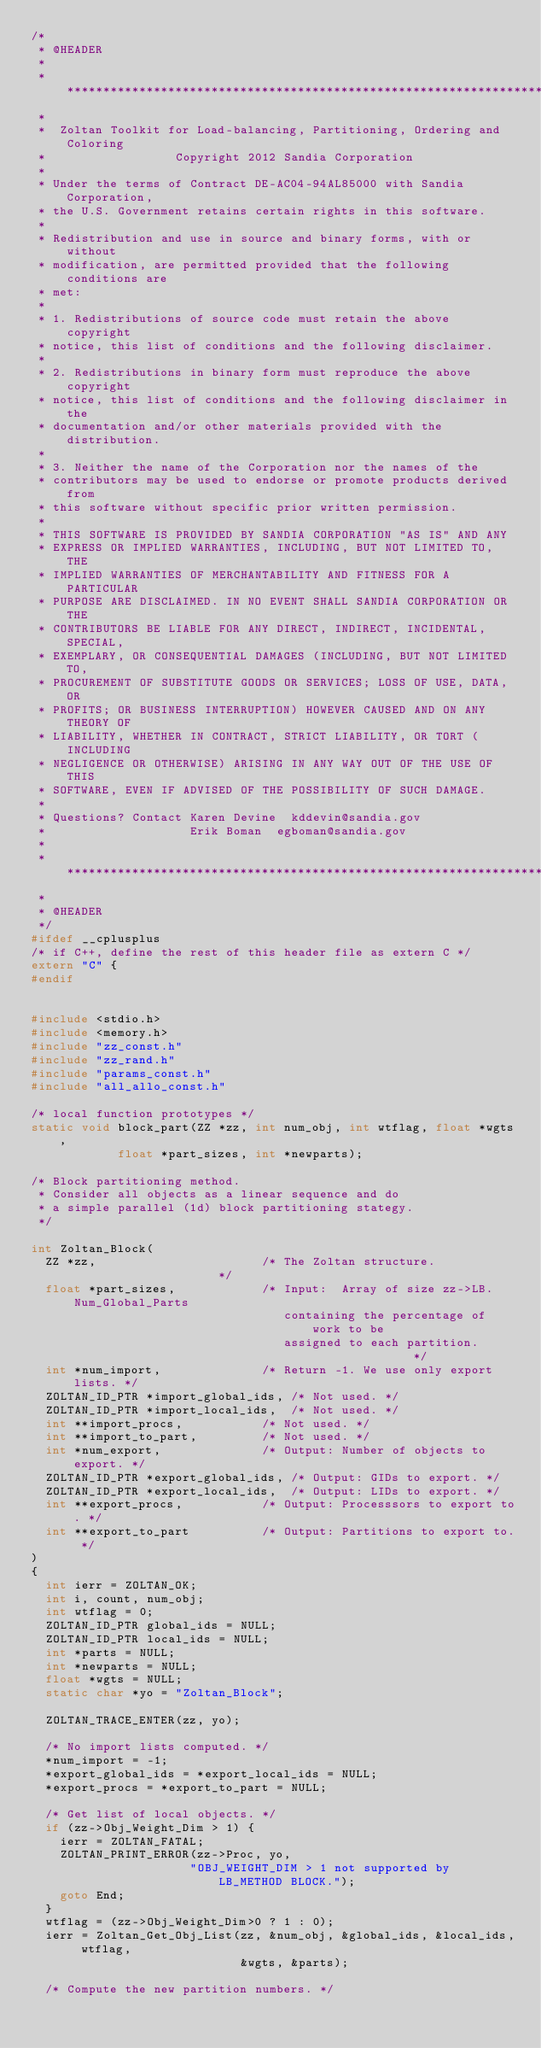<code> <loc_0><loc_0><loc_500><loc_500><_C_>/* 
 * @HEADER
 *
 * ***********************************************************************
 *
 *  Zoltan Toolkit for Load-balancing, Partitioning, Ordering and Coloring
 *                  Copyright 2012 Sandia Corporation
 *
 * Under the terms of Contract DE-AC04-94AL85000 with Sandia Corporation,
 * the U.S. Government retains certain rights in this software.
 *
 * Redistribution and use in source and binary forms, with or without
 * modification, are permitted provided that the following conditions are
 * met:
 *
 * 1. Redistributions of source code must retain the above copyright
 * notice, this list of conditions and the following disclaimer.
 *
 * 2. Redistributions in binary form must reproduce the above copyright
 * notice, this list of conditions and the following disclaimer in the
 * documentation and/or other materials provided with the distribution.
 *
 * 3. Neither the name of the Corporation nor the names of the
 * contributors may be used to endorse or promote products derived from
 * this software without specific prior written permission.
 *
 * THIS SOFTWARE IS PROVIDED BY SANDIA CORPORATION "AS IS" AND ANY
 * EXPRESS OR IMPLIED WARRANTIES, INCLUDING, BUT NOT LIMITED TO, THE
 * IMPLIED WARRANTIES OF MERCHANTABILITY AND FITNESS FOR A PARTICULAR
 * PURPOSE ARE DISCLAIMED. IN NO EVENT SHALL SANDIA CORPORATION OR THE
 * CONTRIBUTORS BE LIABLE FOR ANY DIRECT, INDIRECT, INCIDENTAL, SPECIAL,
 * EXEMPLARY, OR CONSEQUENTIAL DAMAGES (INCLUDING, BUT NOT LIMITED TO,
 * PROCUREMENT OF SUBSTITUTE GOODS OR SERVICES; LOSS OF USE, DATA, OR
 * PROFITS; OR BUSINESS INTERRUPTION) HOWEVER CAUSED AND ON ANY THEORY OF
 * LIABILITY, WHETHER IN CONTRACT, STRICT LIABILITY, OR TORT (INCLUDING
 * NEGLIGENCE OR OTHERWISE) ARISING IN ANY WAY OUT OF THE USE OF THIS
 * SOFTWARE, EVEN IF ADVISED OF THE POSSIBILITY OF SUCH DAMAGE.
 *
 * Questions? Contact Karen Devine	kddevin@sandia.gov
 *                    Erik Boman	egboman@sandia.gov
 *
 * ***********************************************************************
 *
 * @HEADER
 */
#ifdef __cplusplus
/* if C++, define the rest of this header file as extern C */
extern "C" {
#endif


#include <stdio.h>
#include <memory.h>
#include "zz_const.h"
#include "zz_rand.h"
#include "params_const.h"
#include "all_allo_const.h"

/* local function prototypes */
static void block_part(ZZ *zz, int num_obj, int wtflag, float *wgts, 
            float *part_sizes, int *newparts);

/* Block partitioning method.
 * Consider all objects as a linear sequence and do
 * a simple parallel (1d) block partitioning stategy.
 */

int Zoltan_Block(
  ZZ *zz,                       /* The Zoltan structure.                     */
  float *part_sizes,            /* Input:  Array of size zz->LB.Num_Global_Parts
                                   containing the percentage of work to be
                                   assigned to each partition.               */
  int *num_import,              /* Return -1. We use only export lists. */
  ZOLTAN_ID_PTR *import_global_ids, /* Not used. */
  ZOLTAN_ID_PTR *import_local_ids,  /* Not used. */
  int **import_procs,           /* Not used. */
  int **import_to_part,         /* Not used. */
  int *num_export,              /* Output: Number of objects to export. */
  ZOLTAN_ID_PTR *export_global_ids, /* Output: GIDs to export. */
  ZOLTAN_ID_PTR *export_local_ids,  /* Output: LIDs to export. */
  int **export_procs,           /* Output: Processsors to export to. */
  int **export_to_part          /* Output: Partitions to export to. */
)
{
  int ierr = ZOLTAN_OK;
  int i, count, num_obj;
  int wtflag = 0;
  ZOLTAN_ID_PTR global_ids = NULL;
  ZOLTAN_ID_PTR local_ids = NULL; 
  int *parts = NULL;
  int *newparts = NULL;
  float *wgts = NULL;
  static char *yo = "Zoltan_Block";

  ZOLTAN_TRACE_ENTER(zz, yo);

  /* No import lists computed. */
  *num_import = -1;
  *export_global_ids = *export_local_ids = NULL;
  *export_procs = *export_to_part = NULL;

  /* Get list of local objects. */
  if (zz->Obj_Weight_Dim > 1) {
    ierr = ZOLTAN_FATAL;
    ZOLTAN_PRINT_ERROR(zz->Proc, yo, 
                      "OBJ_WEIGHT_DIM > 1 not supported by LB_METHOD BLOCK.");
    goto End;
  }
  wtflag = (zz->Obj_Weight_Dim>0 ? 1 : 0);
  ierr = Zoltan_Get_Obj_List(zz, &num_obj, &global_ids, &local_ids, wtflag,
                             &wgts, &parts);

  /* Compute the new partition numbers. */</code> 